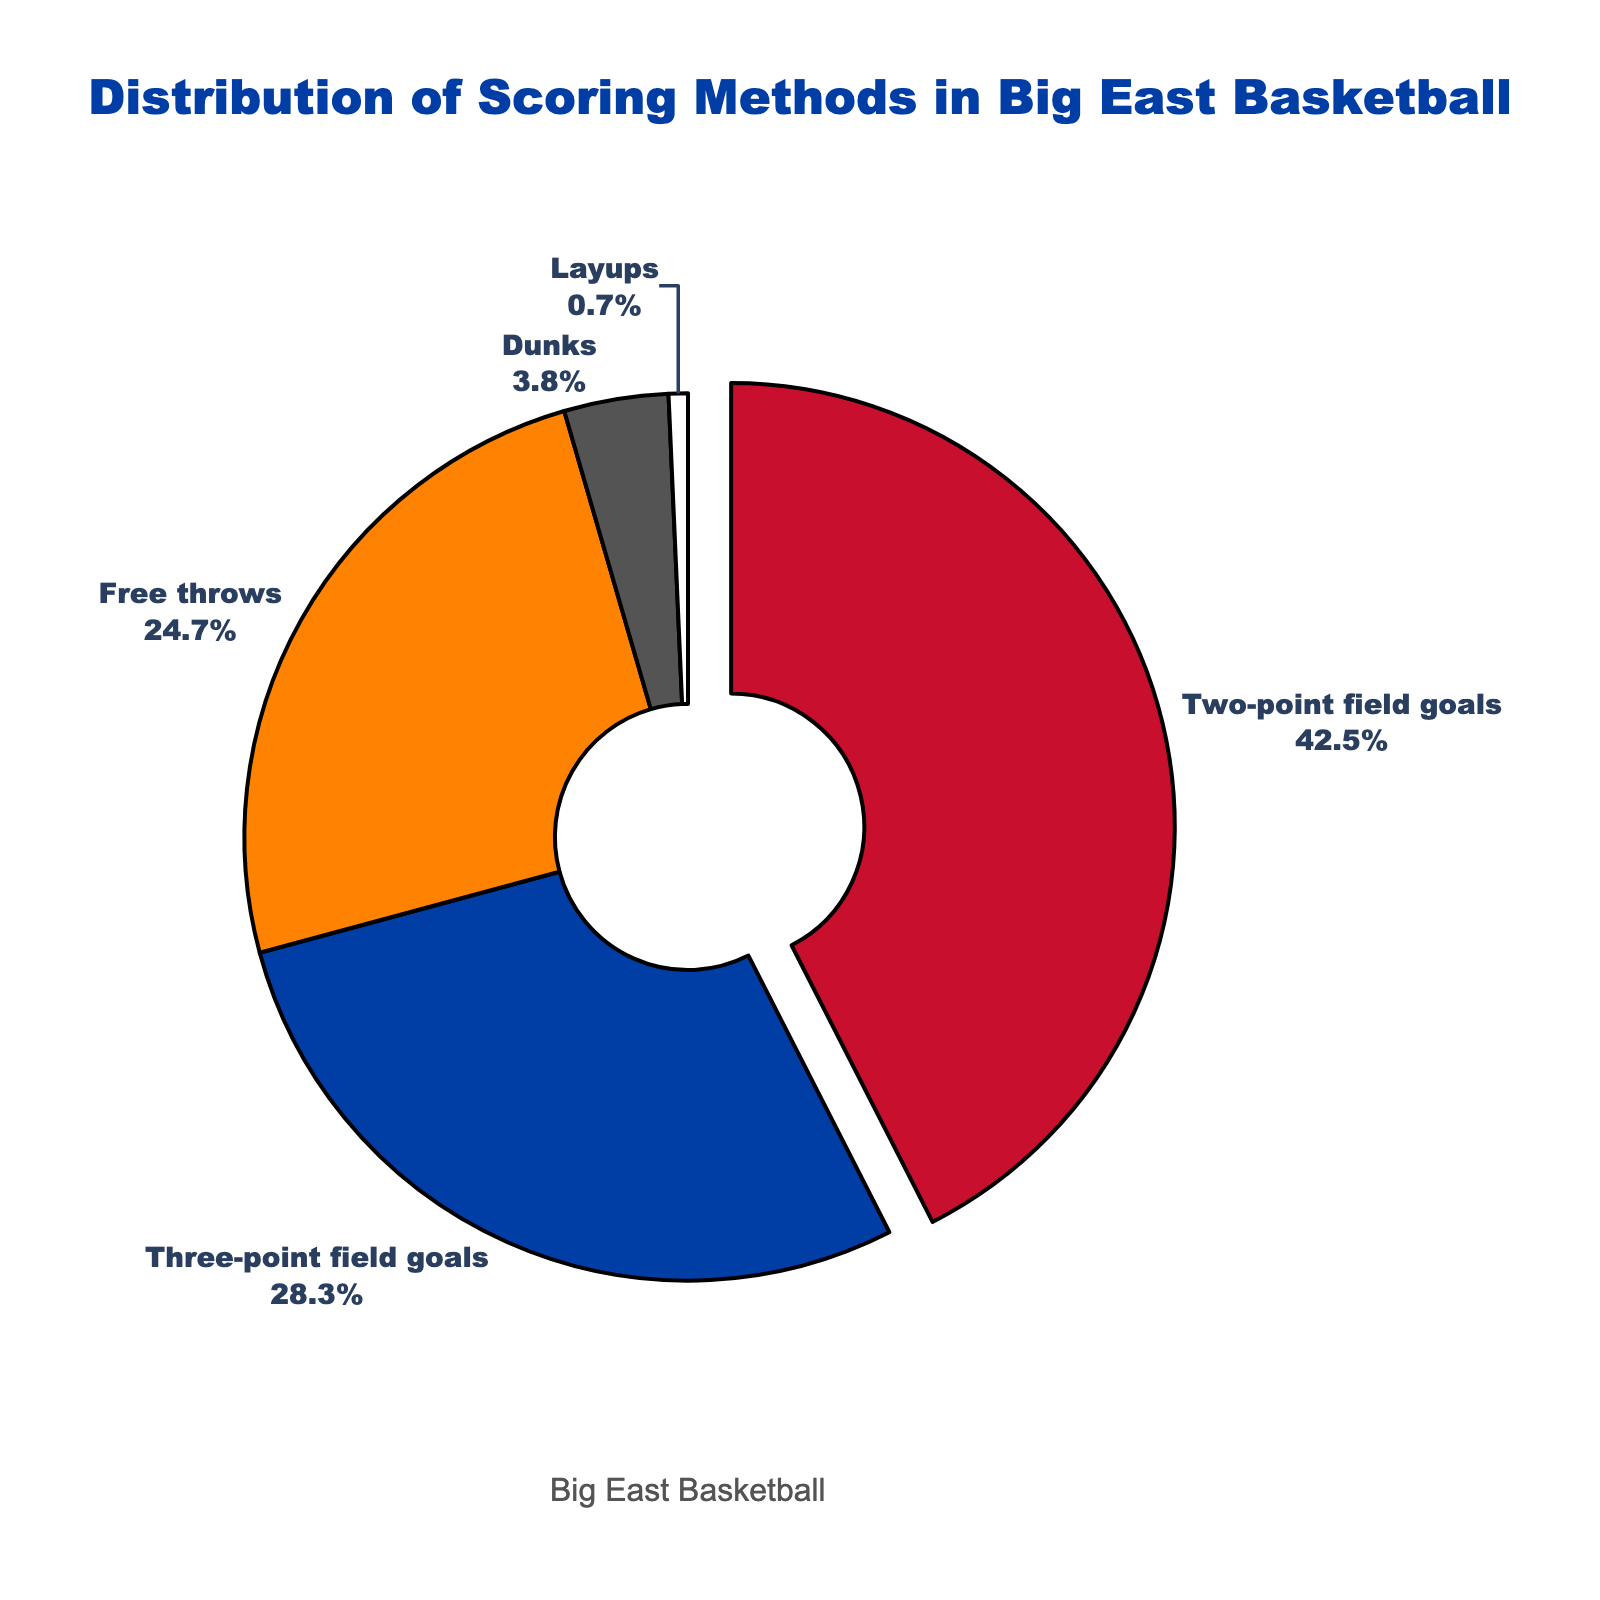What scoring method has the highest percentage? The pie chart indicates percentages of different scoring methods. The segment for Two-point field goals occupies the largest percentage.
Answer: Two-point field goals What two scoring methods combined make up more than 50% of the points? The percentages for Two-point field goals and Three-point field goals are 42.5% and 28.3% respectively. Combining them results in 42.5% + 28.3% = 70.8%.
Answer: Two-point field goals and Three-point field goals Which scoring method is the least common? The segment for Layups represents the smallest percentage in the pie chart.
Answer: Layups Do free throws contribute more to the overall points than dunks and layups combined? Free throws have a percentage of 24.7%, whereas dunks and layups have 3.8% and 0.7% respectively. Adding dunks and layups results in 3.8% + 0.7% = 4.5%, which is less than 24.7%.
Answer: Yes By how much do two-point field goals exceed three-point field goals in terms of percentage? Percentage of two-point field goals is 42.5% and three-point field goals is 28.3%. The difference is 42.5% - 28.3% = 14.2%.
Answer: 14.2% What is the combined percentage of all non-field goal methods? Non-field goal methods include Free throws, Dunks, and Layups with percentages of 24.7%, 3.8%, and 0.7% respectively. Their combined percentage is 24.7% + 3.8% + 0.7% = 29.2%.
Answer: 29.2% Which method is represented by a color close to white? By observing the colors in the pie chart, the segment for Layups is close to white.
Answer: Layups What percentage of shots were made from outside the three-point line? The segment for Three-point field goals indicates a percentage of 28.3%.
Answer: 28.3% Between two-point field goals and free throws, which has a higher percentage and what is the difference in percentage? Two-point field goals have 42.5% and free throws have 24.7%. The difference is 42.5% - 24.7% = 17.8%.
Answer: Two-point field goals, 17.8% 